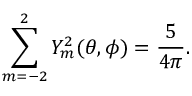Convert formula to latex. <formula><loc_0><loc_0><loc_500><loc_500>\sum _ { m = - 2 } ^ { 2 } Y _ { m } ^ { 2 } ( \theta , \phi ) = \frac { 5 } { 4 \pi } .</formula> 